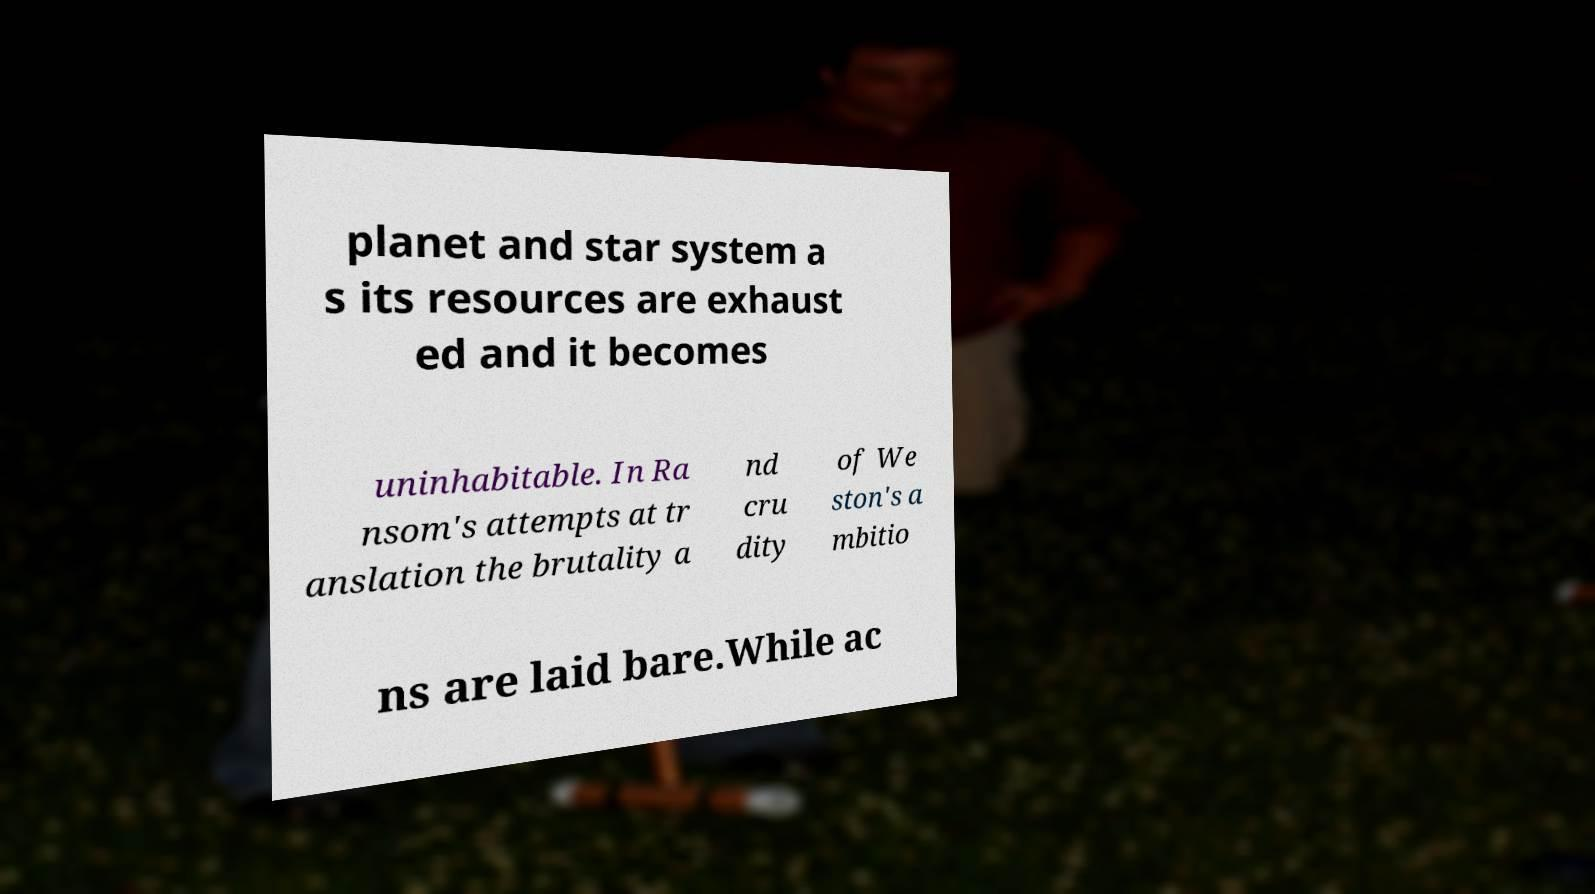I need the written content from this picture converted into text. Can you do that? planet and star system a s its resources are exhaust ed and it becomes uninhabitable. In Ra nsom's attempts at tr anslation the brutality a nd cru dity of We ston's a mbitio ns are laid bare.While ac 